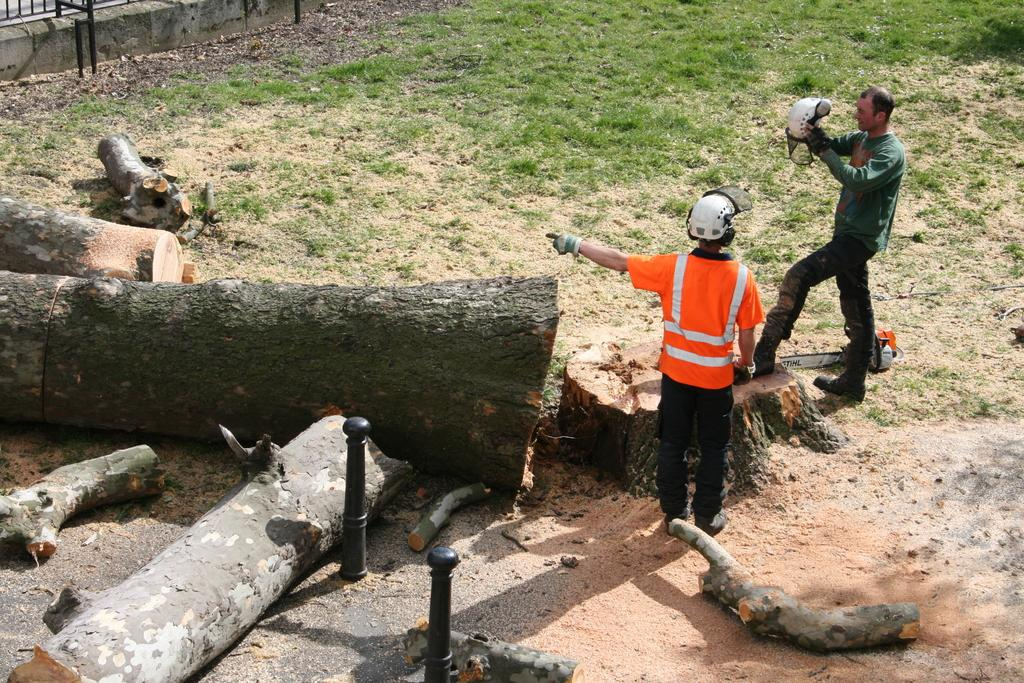How many people are present in the image? There are two people standing in the image. What is one of the people holding in the image? There is a person holding something in the image. What type of natural environment is visible in the image? There is grass visible in the image. What other objects can be seen in the image? There are wooden logs and poles in the image. What type of veil can be seen covering the wooden logs in the image? There is no veil present in the image, and the wooden logs are not covered. How many mice are visible running across the grass in the image? There are no mice visible in the image; only the two people, wooden logs, poles, and grass can be seen. 